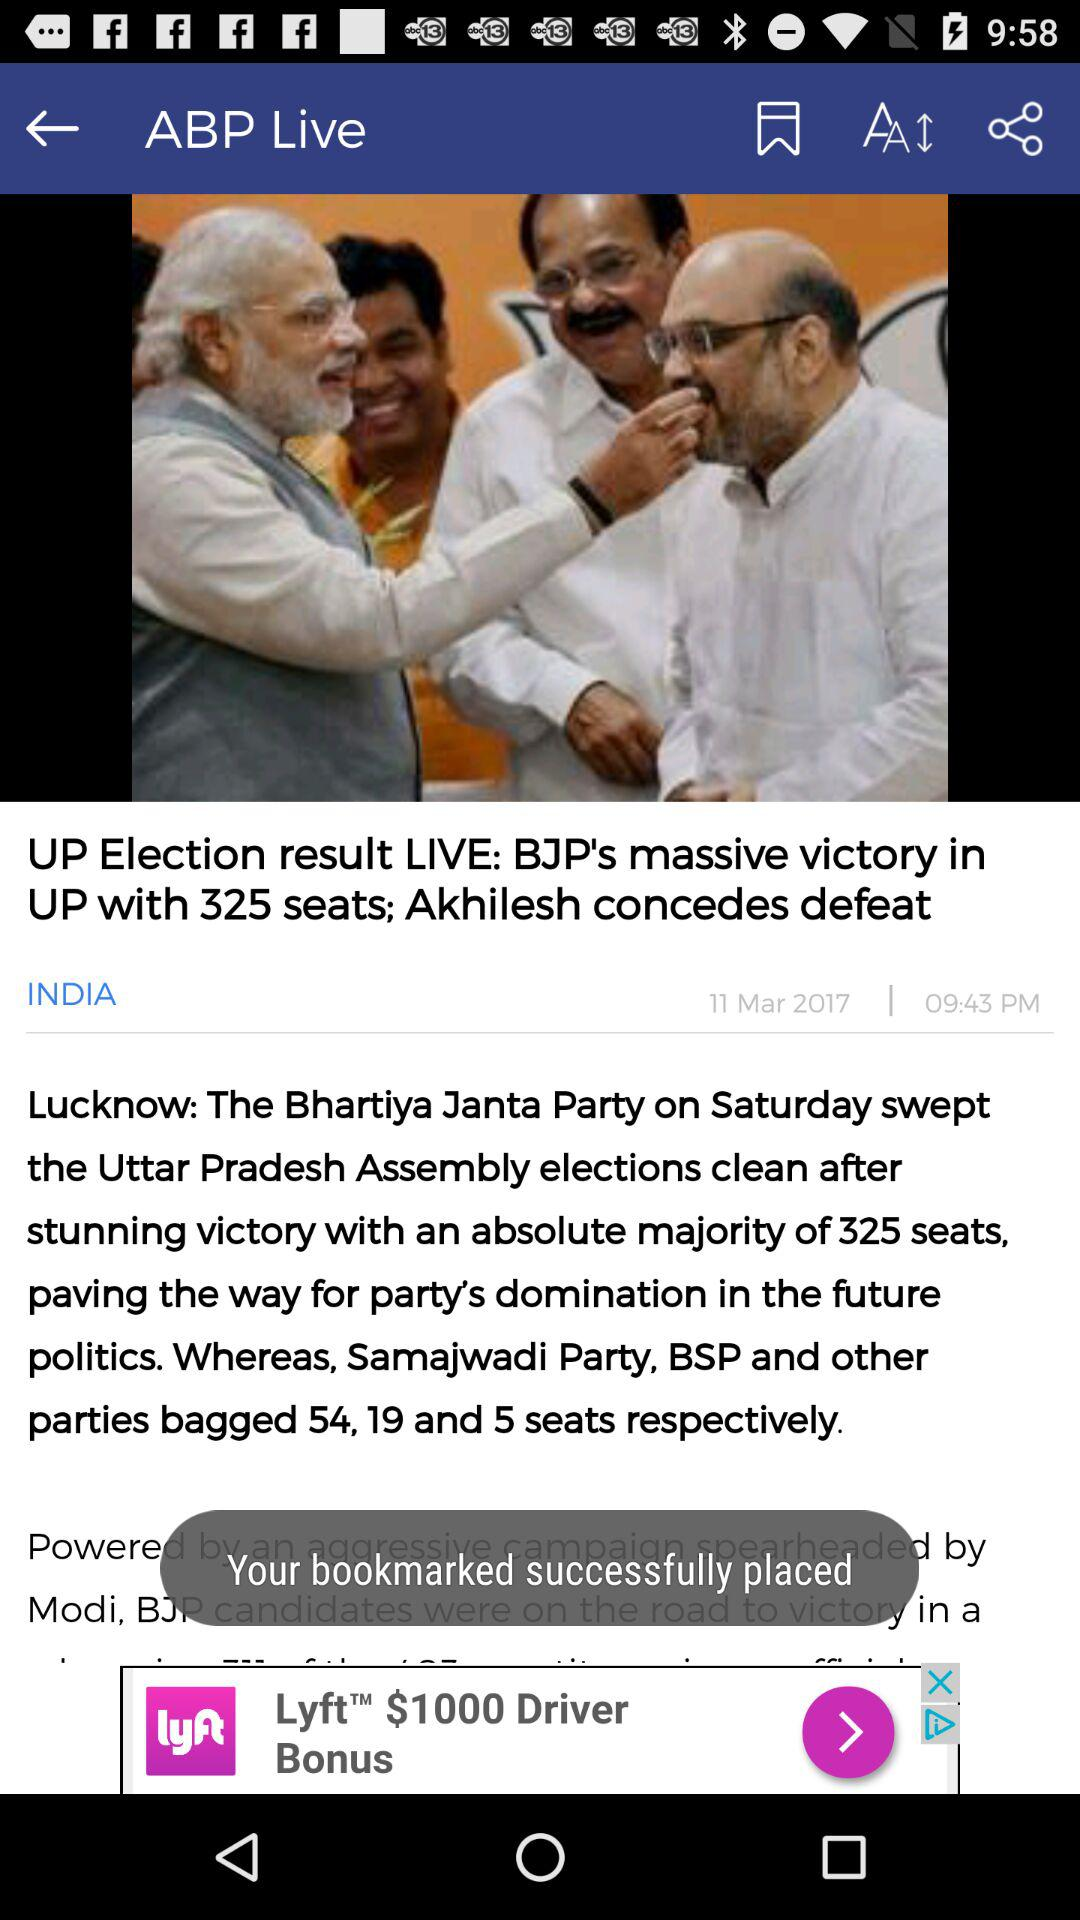What is the title of the news? The title of the news is "UP Election result LIVE: BJP's massive victory in UP with 325 seats; Akhilesh concedes defeat". 